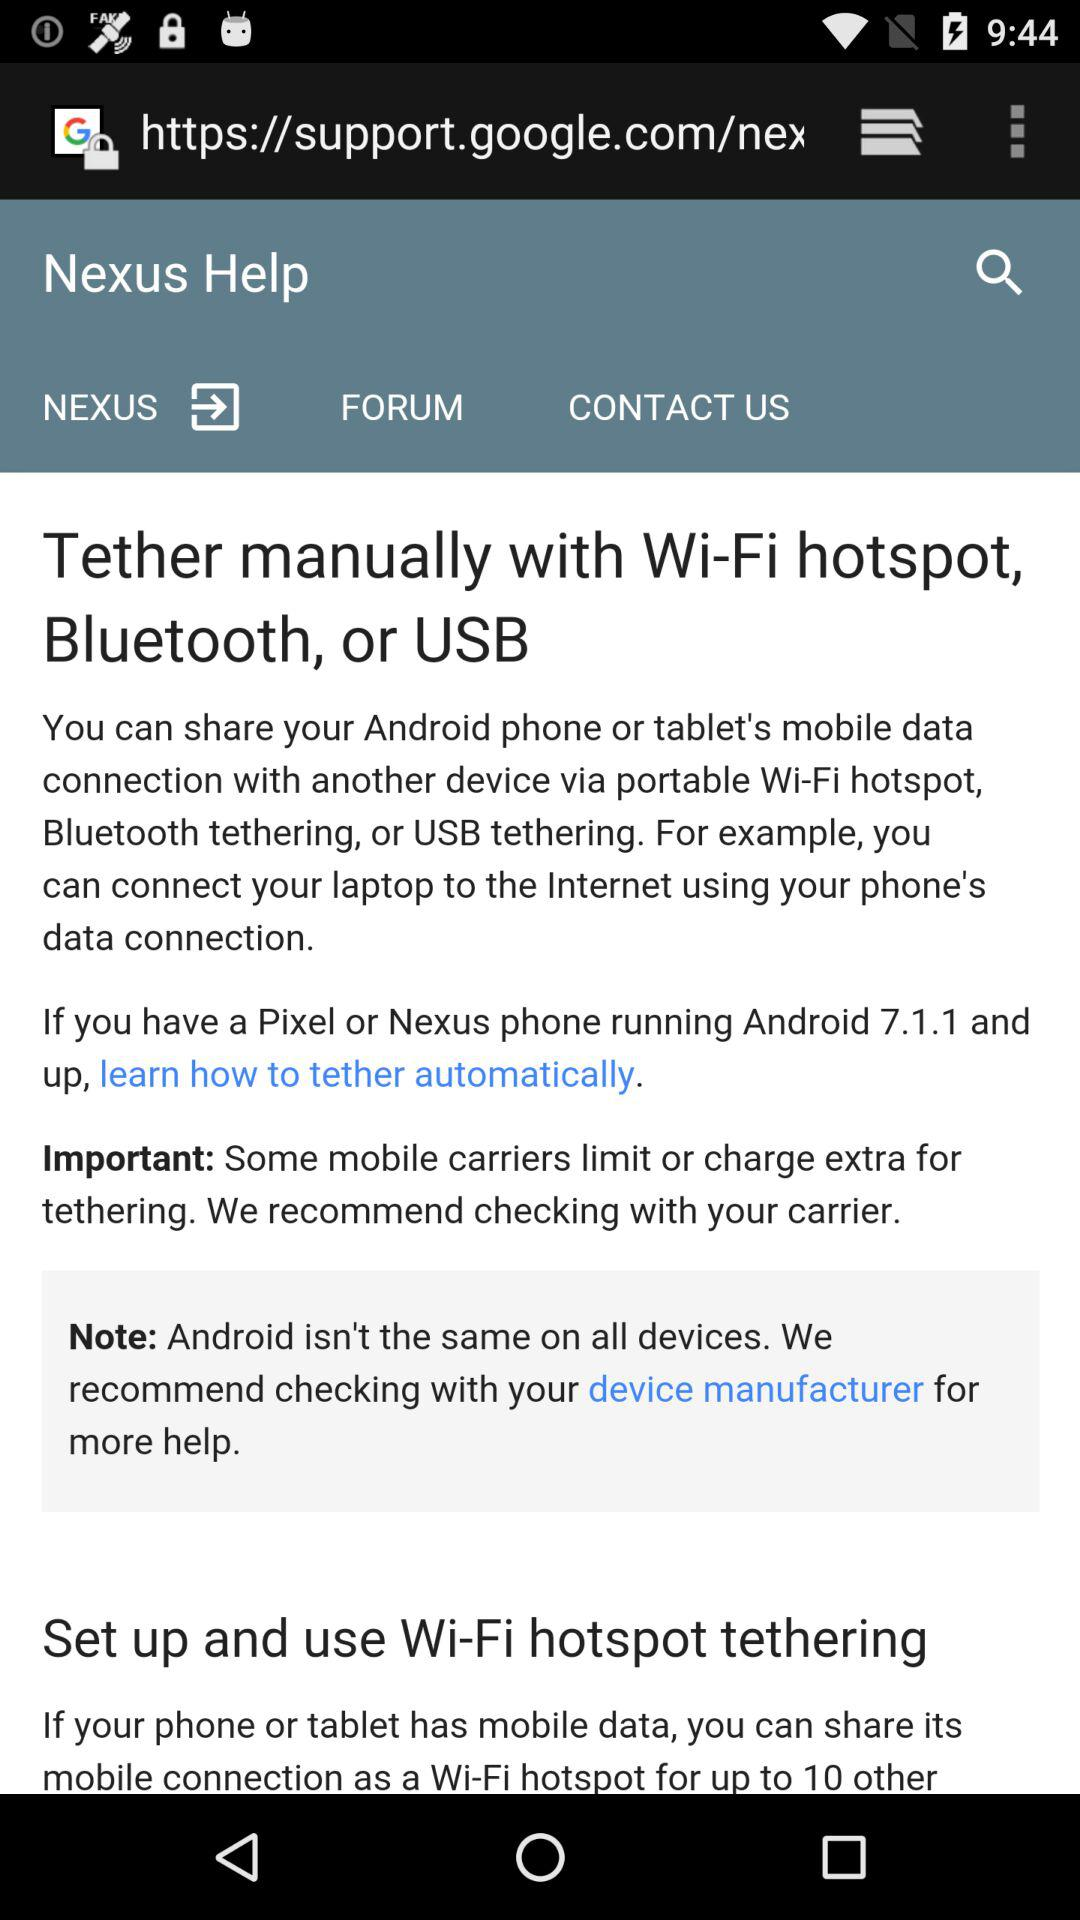How many ways can you manually tether your Android device?
Answer the question using a single word or phrase. 3 